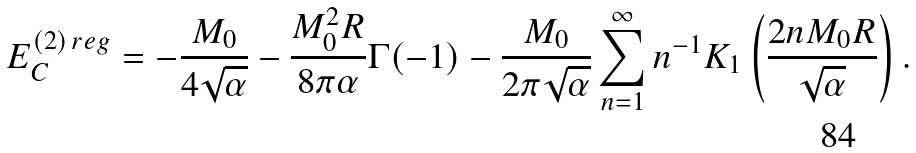Convert formula to latex. <formula><loc_0><loc_0><loc_500><loc_500>E _ { C } ^ { ( 2 ) \, r e g } = - \frac { M _ { 0 } } { 4 \sqrt { \alpha } } - \frac { M _ { 0 } ^ { 2 } R } { 8 \pi \alpha } \Gamma ( - 1 ) - \frac { M _ { 0 } } { 2 \pi \sqrt { \alpha } } \sum _ { n = 1 } ^ { \infty } n ^ { - 1 } K _ { 1 } \left ( \frac { 2 n M _ { 0 } R } { \sqrt { \alpha } } \right ) .</formula> 